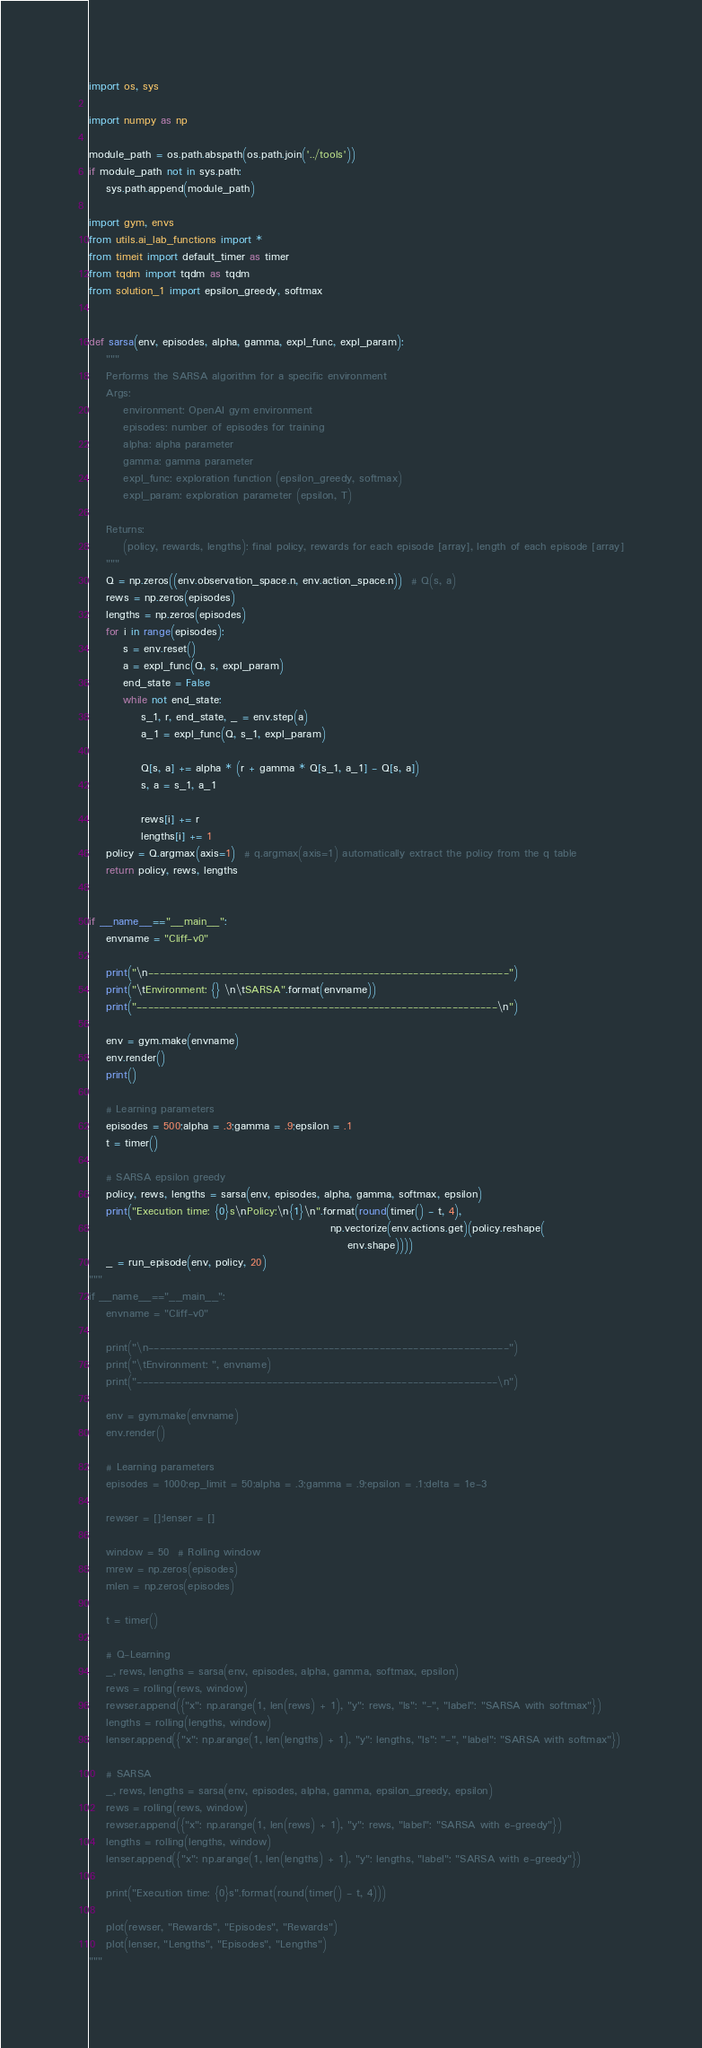Convert code to text. <code><loc_0><loc_0><loc_500><loc_500><_Python_>import os, sys

import numpy as np

module_path = os.path.abspath(os.path.join('../tools'))
if module_path not in sys.path:
    sys.path.append(module_path)

import gym, envs
from utils.ai_lab_functions import *
from timeit import default_timer as timer
from tqdm import tqdm as tqdm
from solution_1 import epsilon_greedy, softmax


def sarsa(env, episodes, alpha, gamma, expl_func, expl_param):
    """
    Performs the SARSA algorithm for a specific environment
    Args:
        environment: OpenAI gym environment
        episodes: number of episodes for training
        alpha: alpha parameter
        gamma: gamma parameter
        expl_func: exploration function (epsilon_greedy, softmax)
        expl_param: exploration parameter (epsilon, T)

    Returns:
        (policy, rewards, lengths): final policy, rewards for each episode [array], length of each episode [array]
    """
    Q = np.zeros((env.observation_space.n, env.action_space.n))  # Q(s, a)
    rews = np.zeros(episodes)
    lengths = np.zeros(episodes)
    for i in range(episodes):
        s = env.reset()
        a = expl_func(Q, s, expl_param)
        end_state = False
        while not end_state:
            s_1, r, end_state, _ = env.step(a)
            a_1 = expl_func(Q, s_1, expl_param)

            Q[s, a] += alpha * (r + gamma * Q[s_1, a_1] - Q[s, a])
            s, a = s_1, a_1

            rews[i] += r
            lengths[i] += 1
    policy = Q.argmax(axis=1)  # q.argmax(axis=1) automatically extract the policy from the q table
    return policy, rews, lengths


if __name__=="__main__":
    envname = "Cliff-v0"

    print("\n----------------------------------------------------------------")
    print("\tEnvironment: {} \n\tSARSA".format(envname))
    print("----------------------------------------------------------------\n")

    env = gym.make(envname)
    env.render()
    print()

    # Learning parameters
    episodes = 500;alpha = .3;gamma = .9;epsilon = .1
    t = timer()

    # SARSA epsilon greedy
    policy, rews, lengths = sarsa(env, episodes, alpha, gamma, softmax, epsilon)
    print("Execution time: {0}s\nPolicy:\n{1}\n".format(round(timer() - t, 4),
                                                        np.vectorize(env.actions.get)(policy.reshape(
                                                            env.shape))))
    _ = run_episode(env, policy, 20)
"""
if __name__=="__main__":
    envname = "Cliff-v0"

    print("\n----------------------------------------------------------------")
    print("\tEnvironment: ", envname)
    print("----------------------------------------------------------------\n")

    env = gym.make(envname)
    env.render()

    # Learning parameters
    episodes = 1000;ep_limit = 50;alpha = .3;gamma = .9;epsilon = .1;delta = 1e-3

    rewser = [];lenser = []

    window = 50  # Rolling window
    mrew = np.zeros(episodes)
    mlen = np.zeros(episodes)

    t = timer()

    # Q-Learning
    _, rews, lengths = sarsa(env, episodes, alpha, gamma, softmax, epsilon)
    rews = rolling(rews, window)
    rewser.append({"x": np.arange(1, len(rews) + 1), "y": rews, "ls": "-", "label": "SARSA with softmax"})
    lengths = rolling(lengths, window)
    lenser.append({"x": np.arange(1, len(lengths) + 1), "y": lengths, "ls": "-", "label": "SARSA with softmax"})

    # SARSA
    _, rews, lengths = sarsa(env, episodes, alpha, gamma, epsilon_greedy, epsilon)
    rews = rolling(rews, window)
    rewser.append({"x": np.arange(1, len(rews) + 1), "y": rews, "label": "SARSA with e-greedy"})
    lengths = rolling(lengths, window)
    lenser.append({"x": np.arange(1, len(lengths) + 1), "y": lengths, "label": "SARSA with e-greedy"})

    print("Execution time: {0}s".format(round(timer() - t, 4)))

    plot(rewser, "Rewards", "Episodes", "Rewards")
    plot(lenser, "Lengths", "Episodes", "Lengths")
"""</code> 